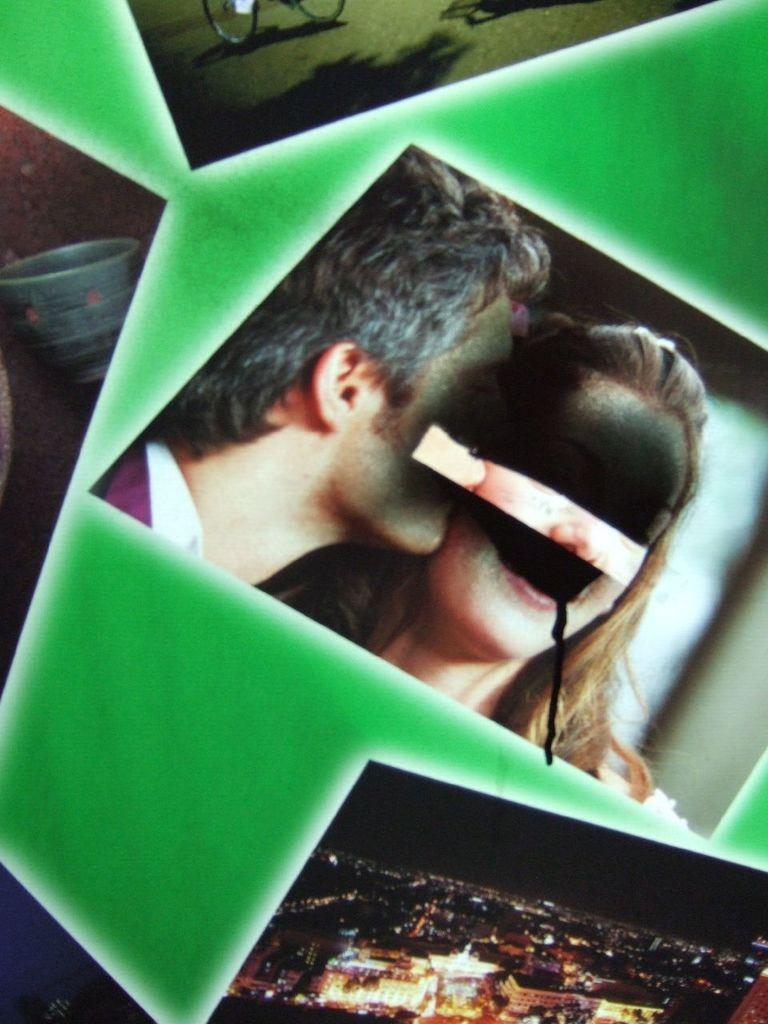How many people are in the image? There are two people in the center of the image. What can be seen at the bottom of the image? There are buildings at the bottom of the image. What type of quince is being used to create a rhythmic meal in the image? There is no quince, rhythm, or meal present in the image. 